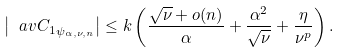Convert formula to latex. <formula><loc_0><loc_0><loc_500><loc_500>\left | \ a v { C _ { 1 } } _ { \psi _ { \alpha , \nu , n } } \right | \leq k \left ( \frac { \sqrt { \nu } + o ( n ) } { \alpha } + \frac { \alpha ^ { 2 } } { \sqrt { \nu } } + \frac { \eta } { \nu ^ { p } } \right ) .</formula> 